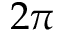Convert formula to latex. <formula><loc_0><loc_0><loc_500><loc_500>2 \pi</formula> 